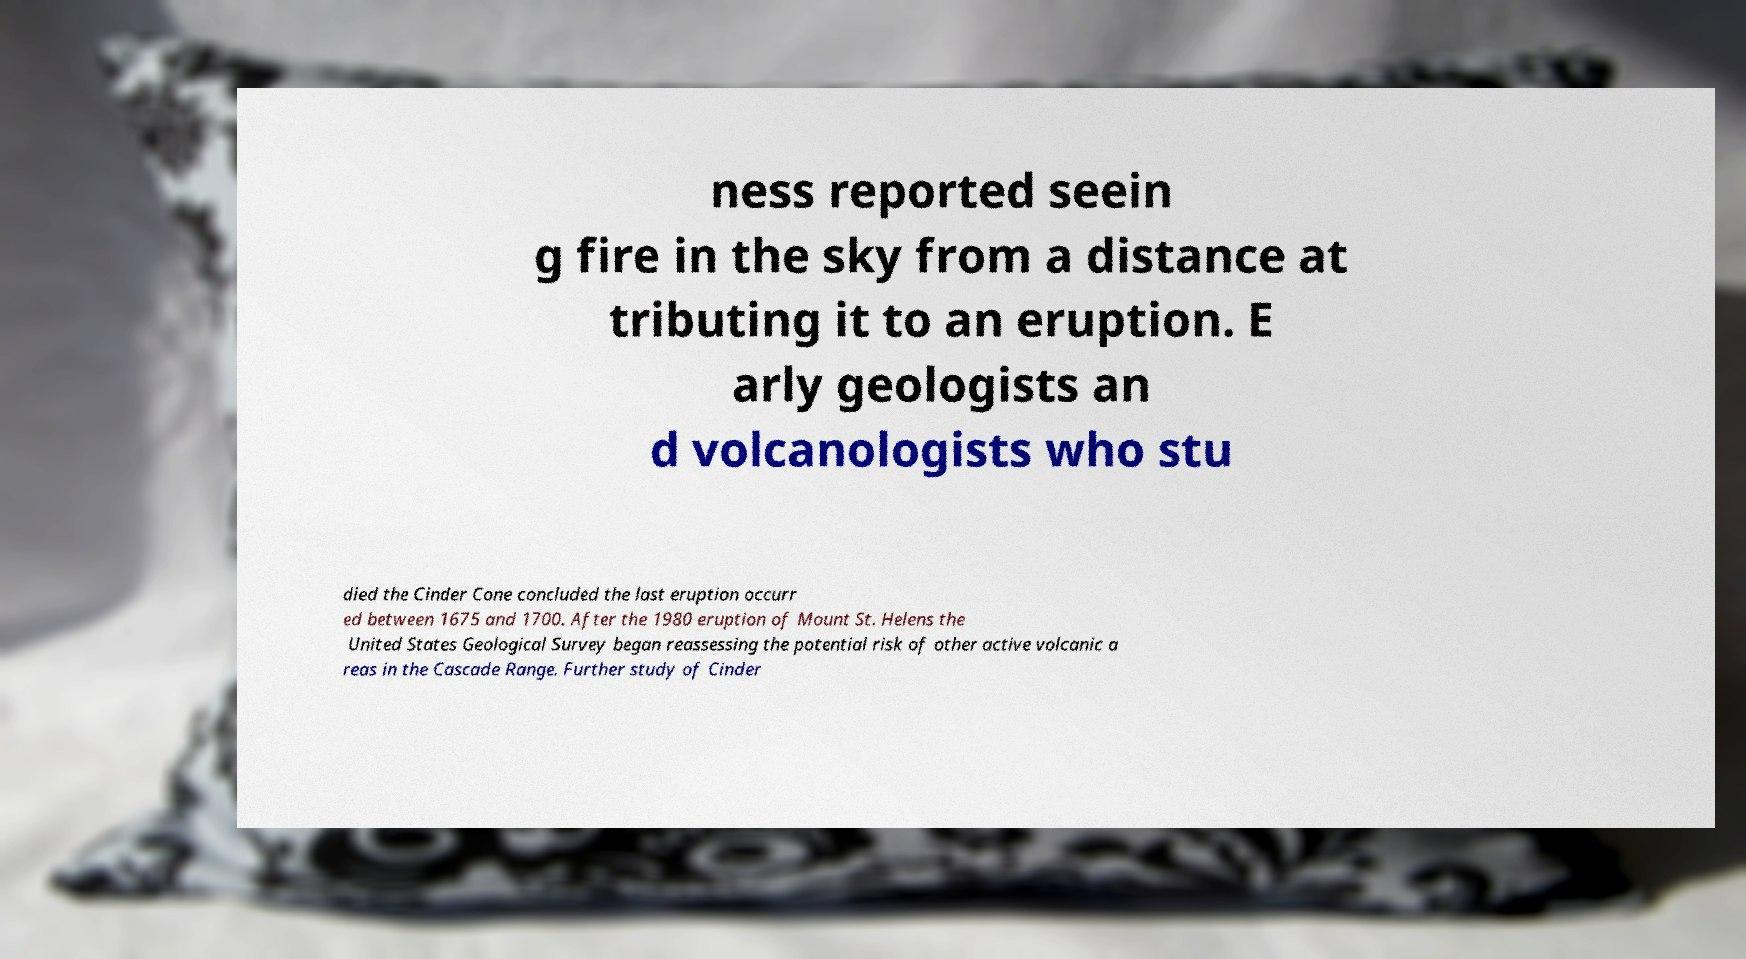Could you extract and type out the text from this image? ness reported seein g fire in the sky from a distance at tributing it to an eruption. E arly geologists an d volcanologists who stu died the Cinder Cone concluded the last eruption occurr ed between 1675 and 1700. After the 1980 eruption of Mount St. Helens the United States Geological Survey began reassessing the potential risk of other active volcanic a reas in the Cascade Range. Further study of Cinder 